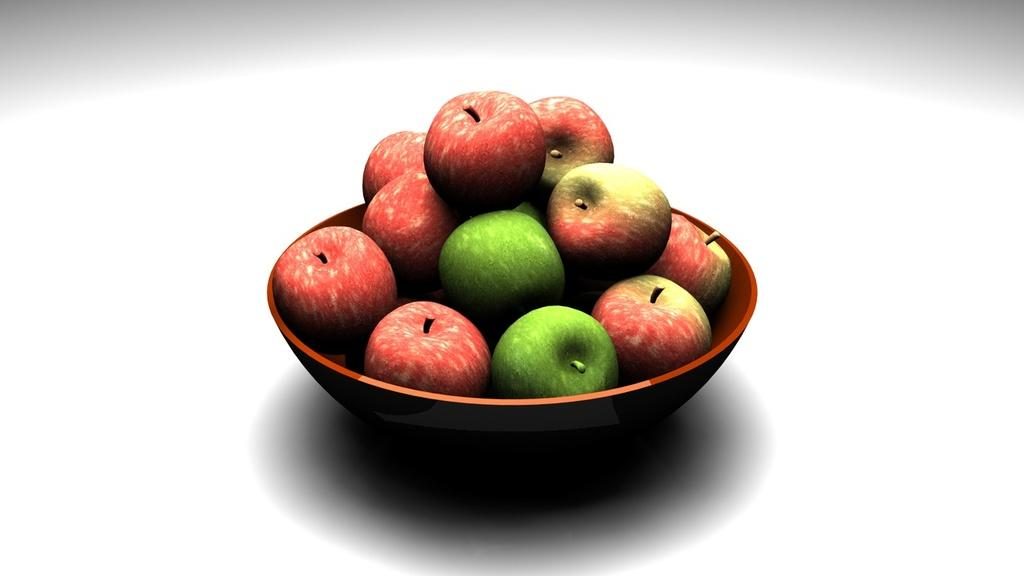What is in the bowl that is visible in the image? There are apples in the bowl in the image. What color is the background of the image? The background of the image is white. What type of whip can be seen cracking in the image? There is no whip present in the image; it features a bowl with apples and a white background. Can you see any ghosts in the image? There are no ghosts present in the image; it features a bowl with apples and a white background. 